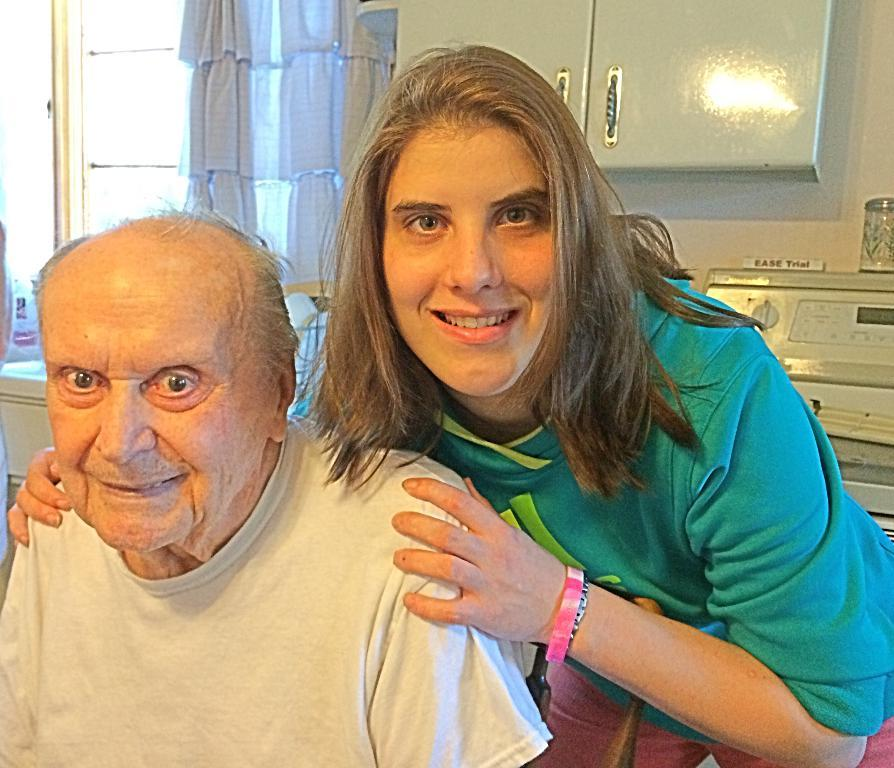How many people are in the image? There are two people in the image. What is the facial expression of the people in the image? The people are smiling. What can be seen in the background of the image? There are cupboards, a wall, a curtain, and some objects visible in the background. What type of stone is used to build the afternoon in the image? There is no reference to an afternoon or stone in the image; it features two people smiling with a background containing cupboards, a wall, a curtain, and some objects. 